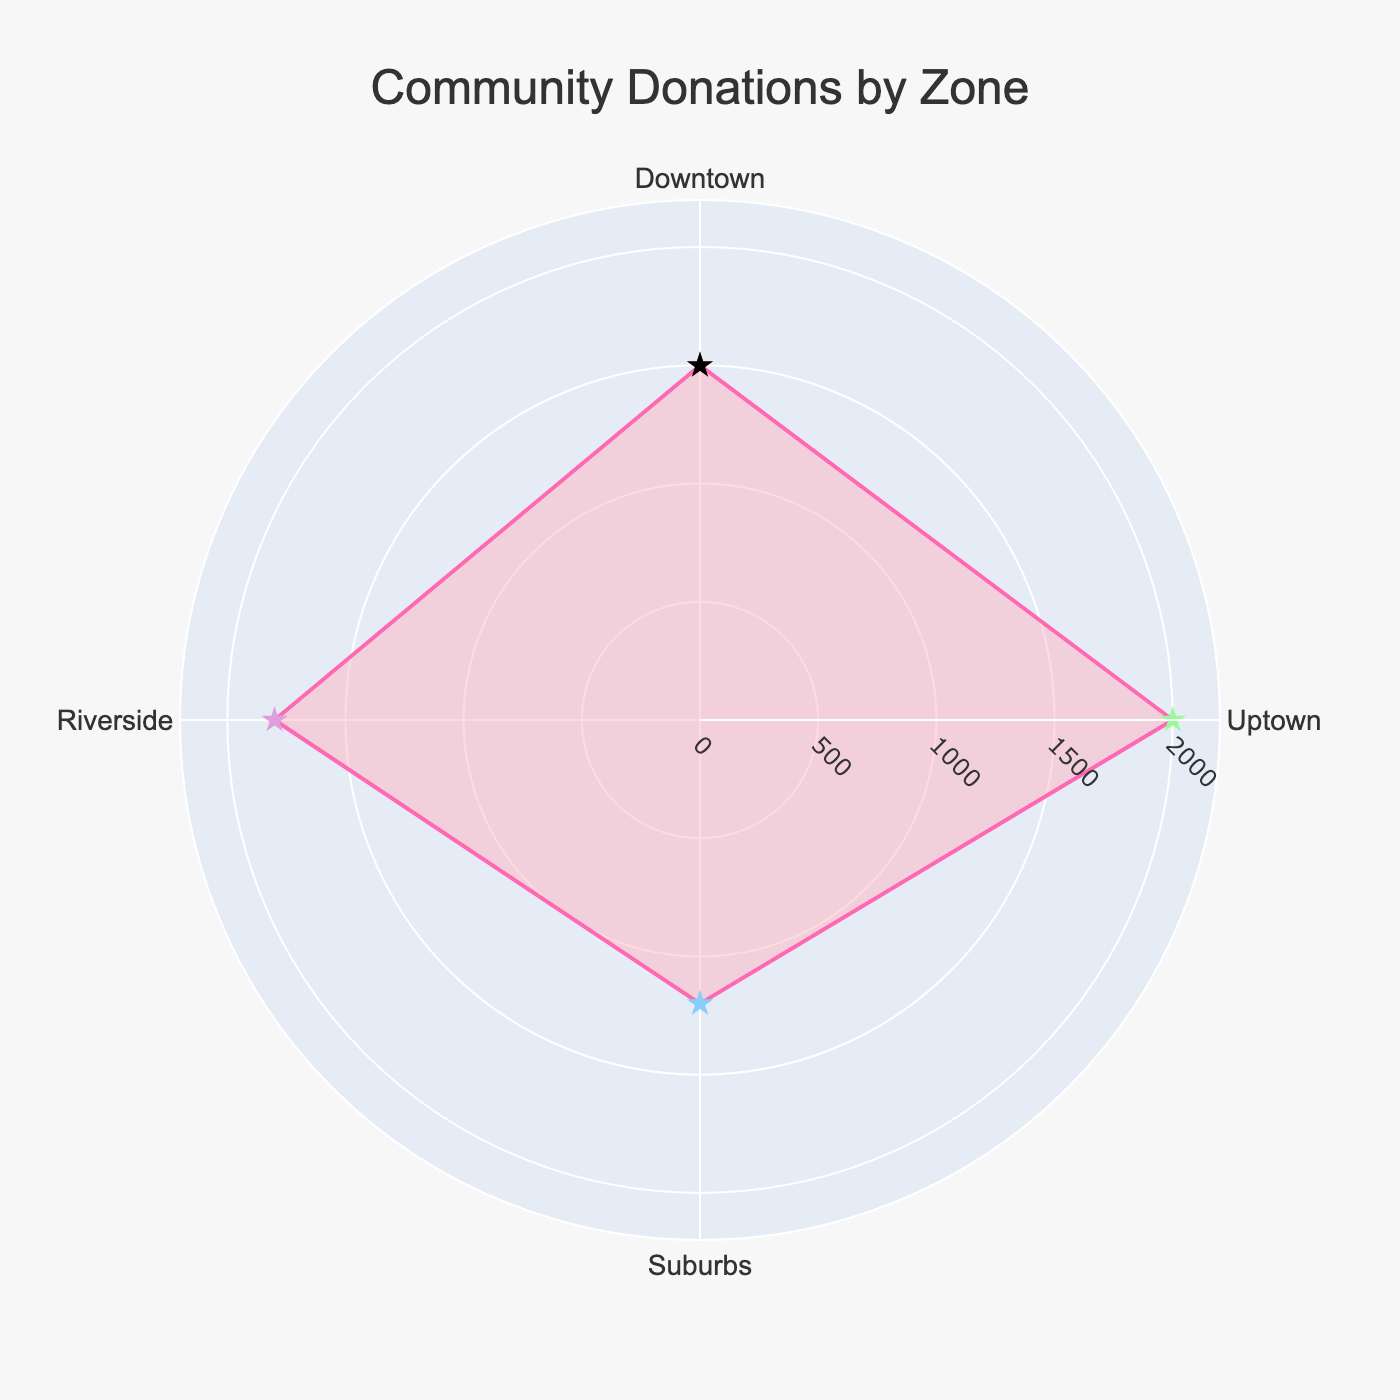What is the title of the figure? The title is visually prominent and typically positioned at the top of the figure. It summarizes the main focus of the chart.
Answer: Community Donations by Zone How many community zones are represented in the figure? Each zone is marked on the angular axis, and the data points correspond to the zones. By counting these, we find there are four zones.
Answer: Four Which zone has the highest total donations? By examining the radial distance of each point, the zone with the farthest point from the center represents the highest donations.
Answer: Uptown What is the range of the donations displayed on the radial axis? The radial axis indicates the minimum and maximum donations. The maximum is slightly higher than the highest donation value reported, which is 2000 USD.
Answer: 0 to 2200 USD How do the donations from Uptown compare to those from the Suburbs? By examining the radial distances of both zones, it is apparent that Uptown has a larger value than the Suburbs. The exact values are 2000 and 1200 USD, respectively.
Answer: Uptown has higher donations than the Suburbs Which zone donated the least amount? The zone with the shortest radial distance from the center has the lowest total donations.
Answer: Suburbs What is the average donation amount across all zones? Summing the donations of all zones (1500 + 2000 + 1200 + 1800 = 6500) and then dividing by the number of zones (4), the average is calculated.
Answer: 1625 USD What is the difference between the highest and the lowest donation amounts? The highest donation is 2000 USD (Uptown) and the lowest is 1200 USD (Suburbs). The difference is calculated by subtracting the lowest from the highest (2000 - 1200).
Answer: 800 USD Which two zones have donations amounts closest to each other, and what is the difference? Comparing the donations from each pair of zones, Downtown (1500 USD) and Riverside (1800 USD) are closest. The difference is calculated by subtracting the smaller from the larger (1800 - 1500).
Answer: Downtown and Riverside, 300 USD 